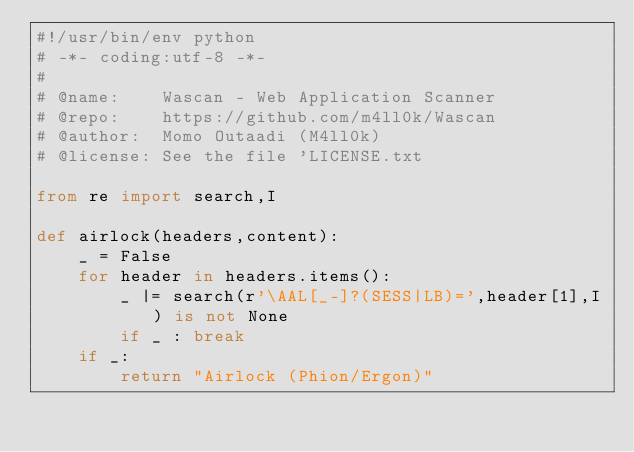<code> <loc_0><loc_0><loc_500><loc_500><_Python_>#!/usr/bin/env python 
# -*- coding:utf-8 -*-
#
# @name:    Wascan - Web Application Scanner
# @repo:    https://github.com/m4ll0k/Wascan
# @author:  Momo Outaadi (M4ll0k)
# @license: See the file 'LICENSE.txt

from re import search,I

def airlock(headers,content):
	_ = False
	for header in headers.items():
		_ |= search(r'\AAL[_-]?(SESS|LB)=',header[1],I) is not None
		if _ : break 
	if _:
		return "Airlock (Phion/Ergon)" </code> 